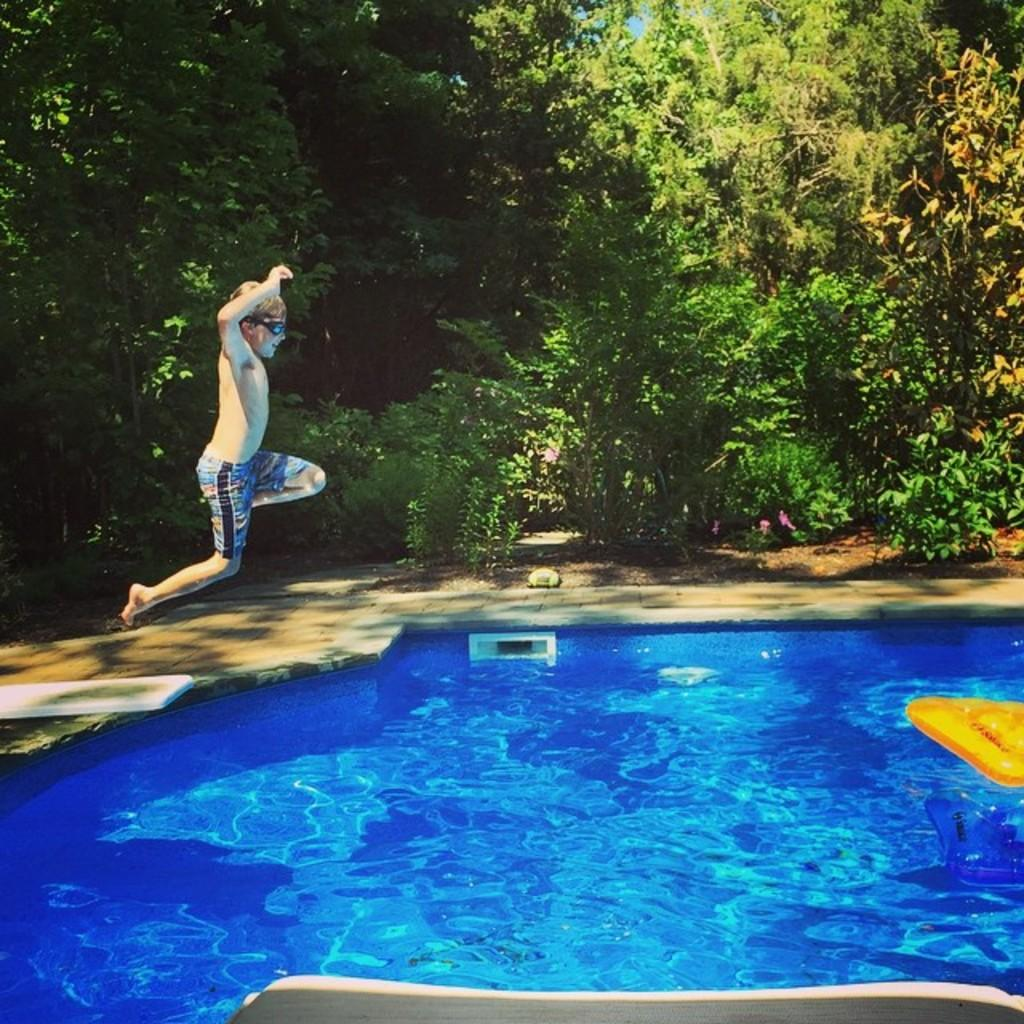What is the main feature in the image? There is a swimming pool in the image. What is the boy in the image doing? A boy is jumping into the pool. What can be seen around the pool? There are plants and trees around the pool. Where is the stage located in the image? There is no stage present in the image. What type of mailbox can be seen near the pool? There is no mailbox present in the image. 